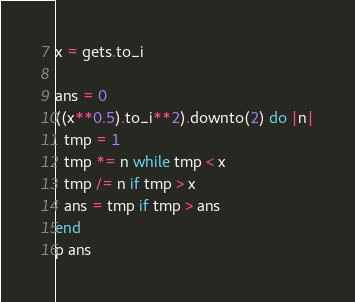<code> <loc_0><loc_0><loc_500><loc_500><_Ruby_>x = gets.to_i

ans = 0
((x**0.5).to_i**2).downto(2) do |n|
  tmp = 1
  tmp *= n while tmp < x
  tmp /= n if tmp > x
  ans = tmp if tmp > ans
end
p ans</code> 